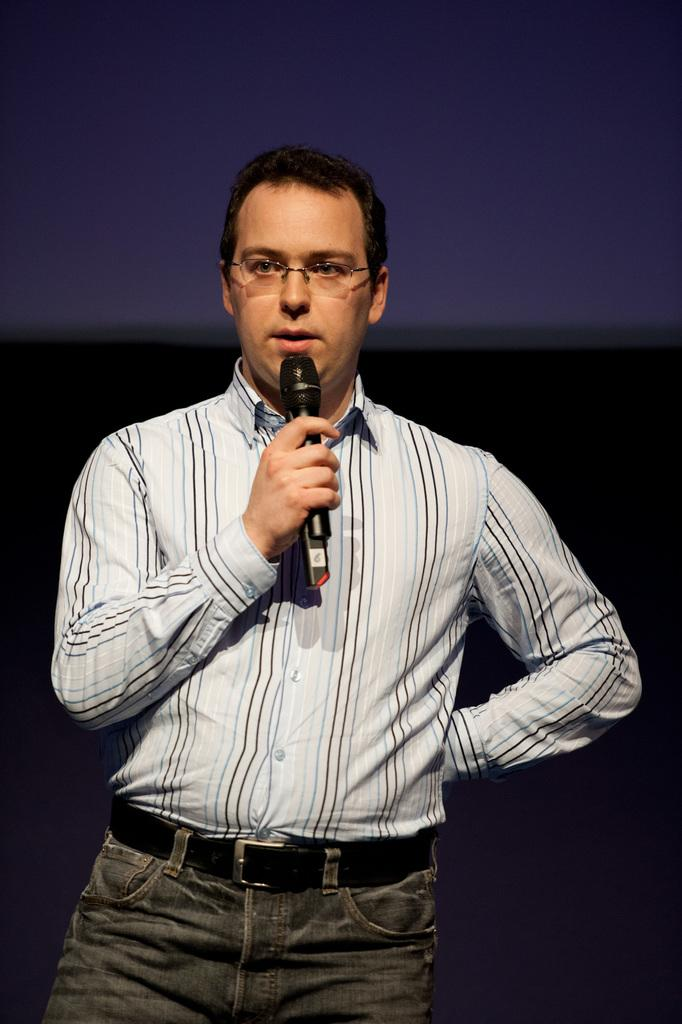What is the man in the image doing? The man appears to be speaking in the image. What is the man wearing on his upper body? The man is wearing a white shirt in the image. What object is the man holding in his hand? The man is holding a microphone in his hand. Can you describe any accessories the man is wearing? The man is wearing spectacles in the image. What type of snake can be seen slithering around the man's feet in the image? There is no snake present in the image; the man is standing alone. 